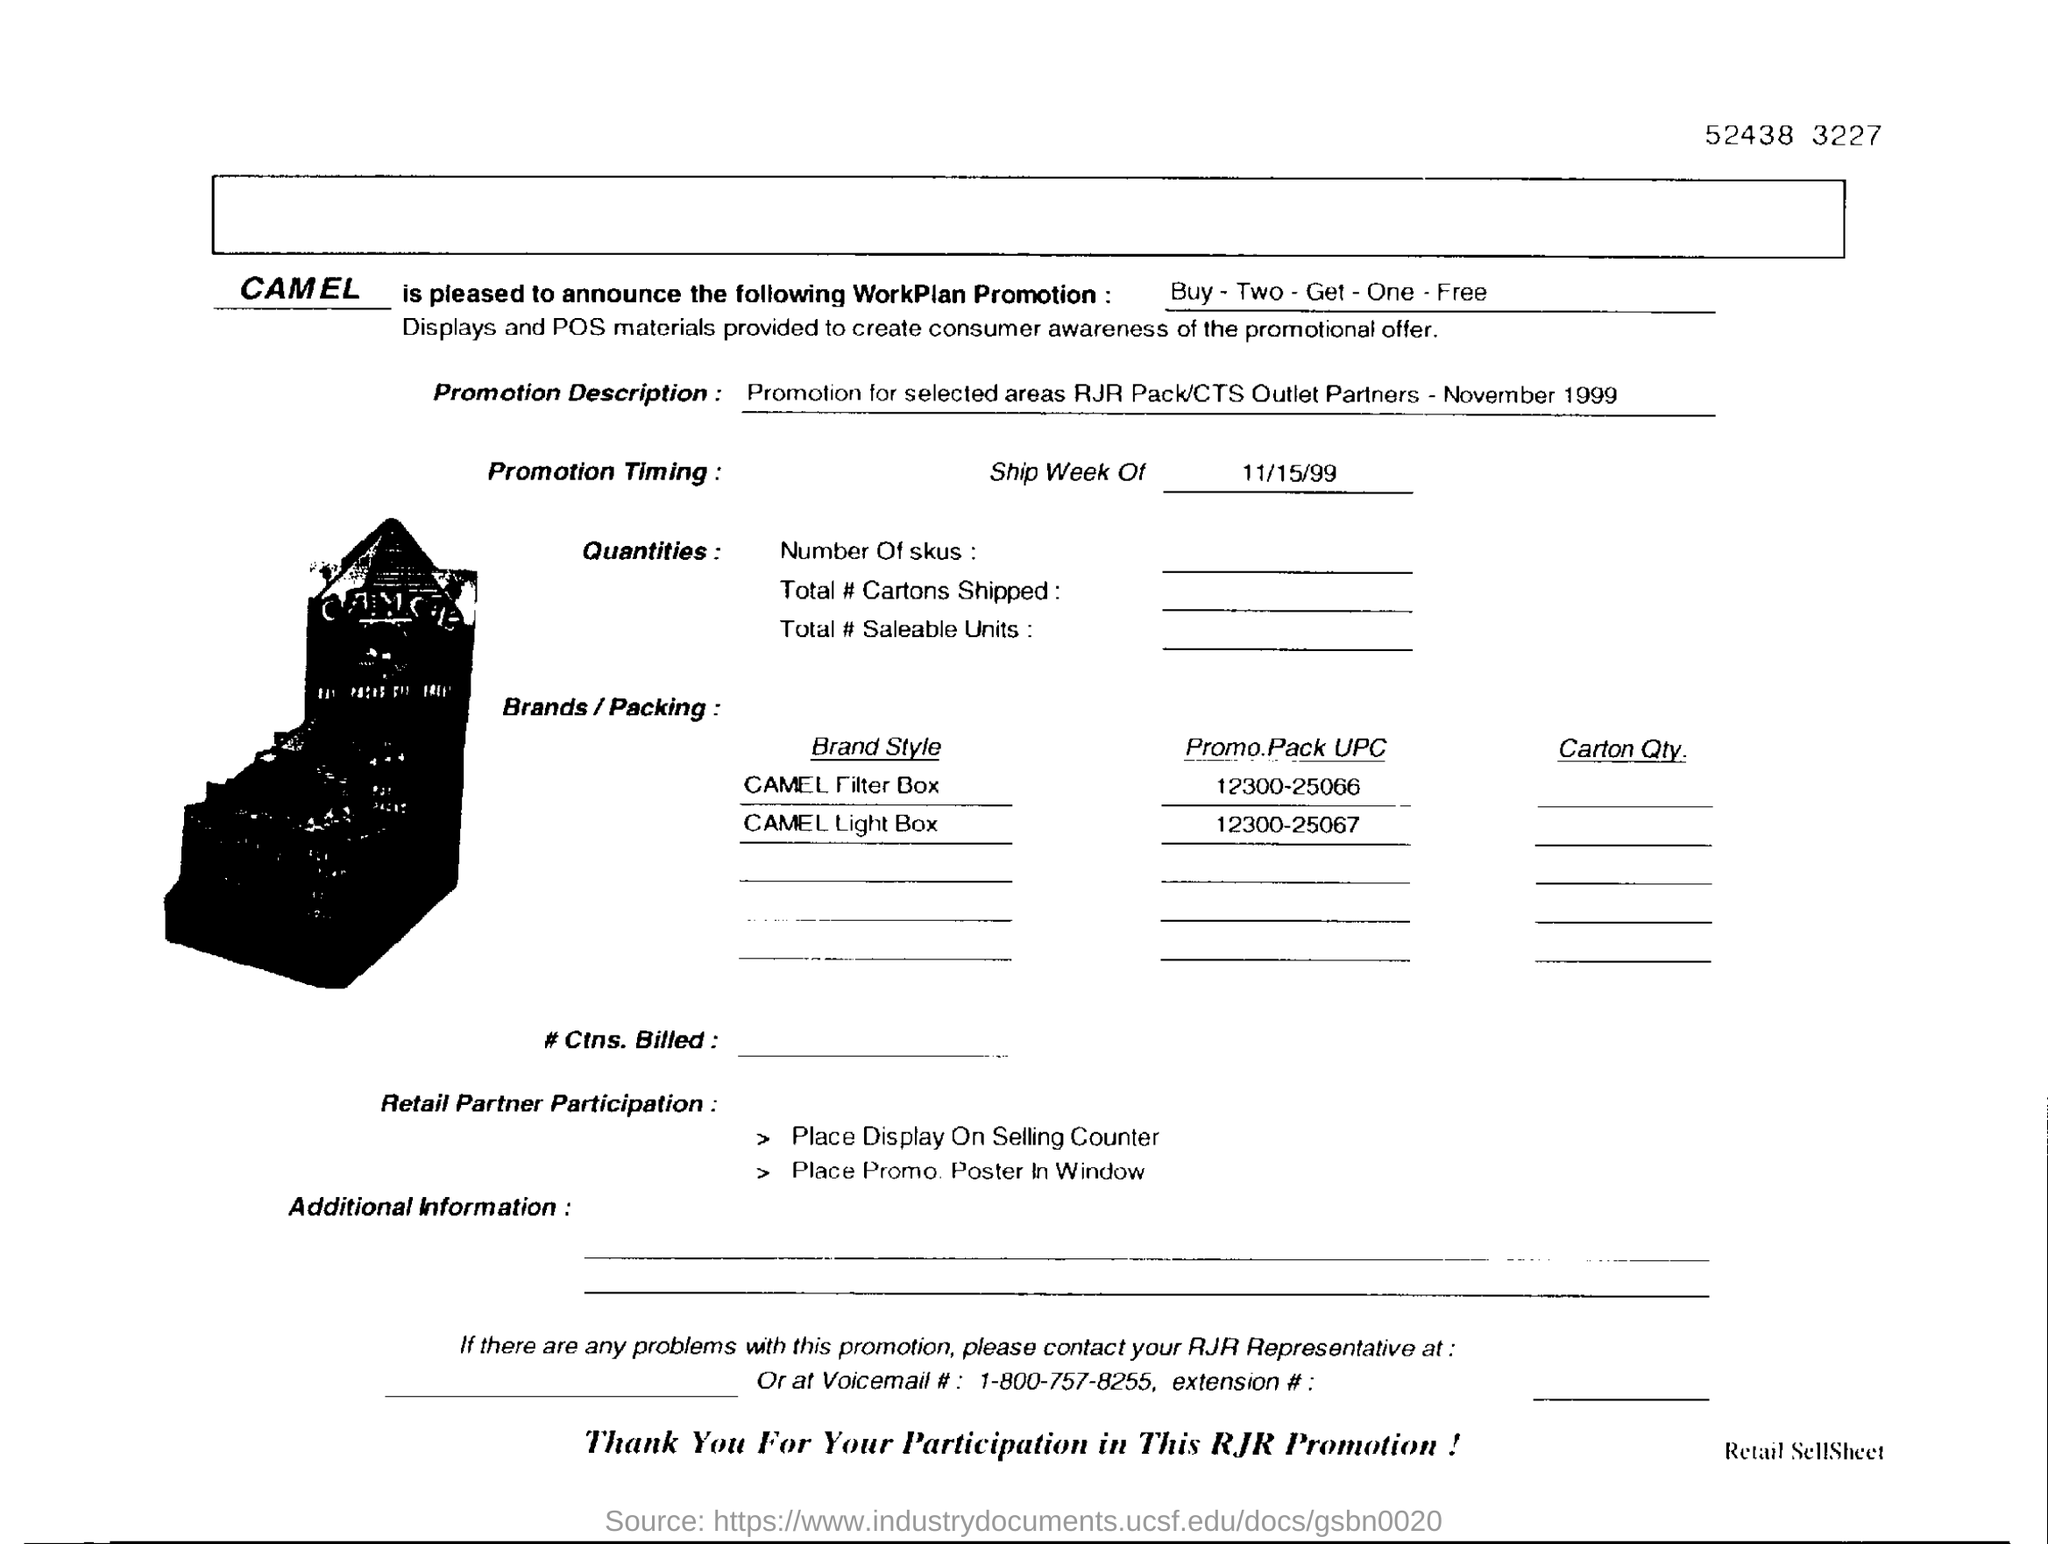Outline some significant characteristics in this image. The given date in the form is the ship week of 11/15/99. The digit shown in the top right corner of the number 52438 is 3. The promotion offers a discount of buying two items and getting one item free. 